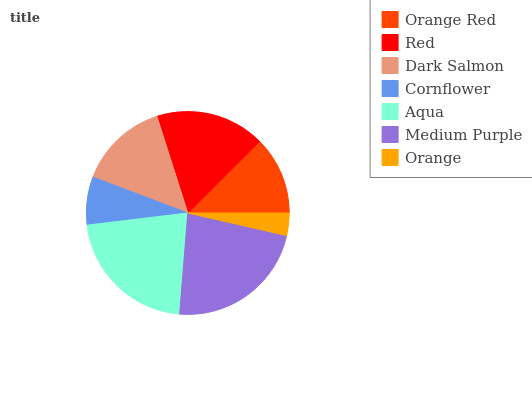Is Orange the minimum?
Answer yes or no. Yes. Is Medium Purple the maximum?
Answer yes or no. Yes. Is Red the minimum?
Answer yes or no. No. Is Red the maximum?
Answer yes or no. No. Is Red greater than Orange Red?
Answer yes or no. Yes. Is Orange Red less than Red?
Answer yes or no. Yes. Is Orange Red greater than Red?
Answer yes or no. No. Is Red less than Orange Red?
Answer yes or no. No. Is Dark Salmon the high median?
Answer yes or no. Yes. Is Dark Salmon the low median?
Answer yes or no. Yes. Is Red the high median?
Answer yes or no. No. Is Aqua the low median?
Answer yes or no. No. 